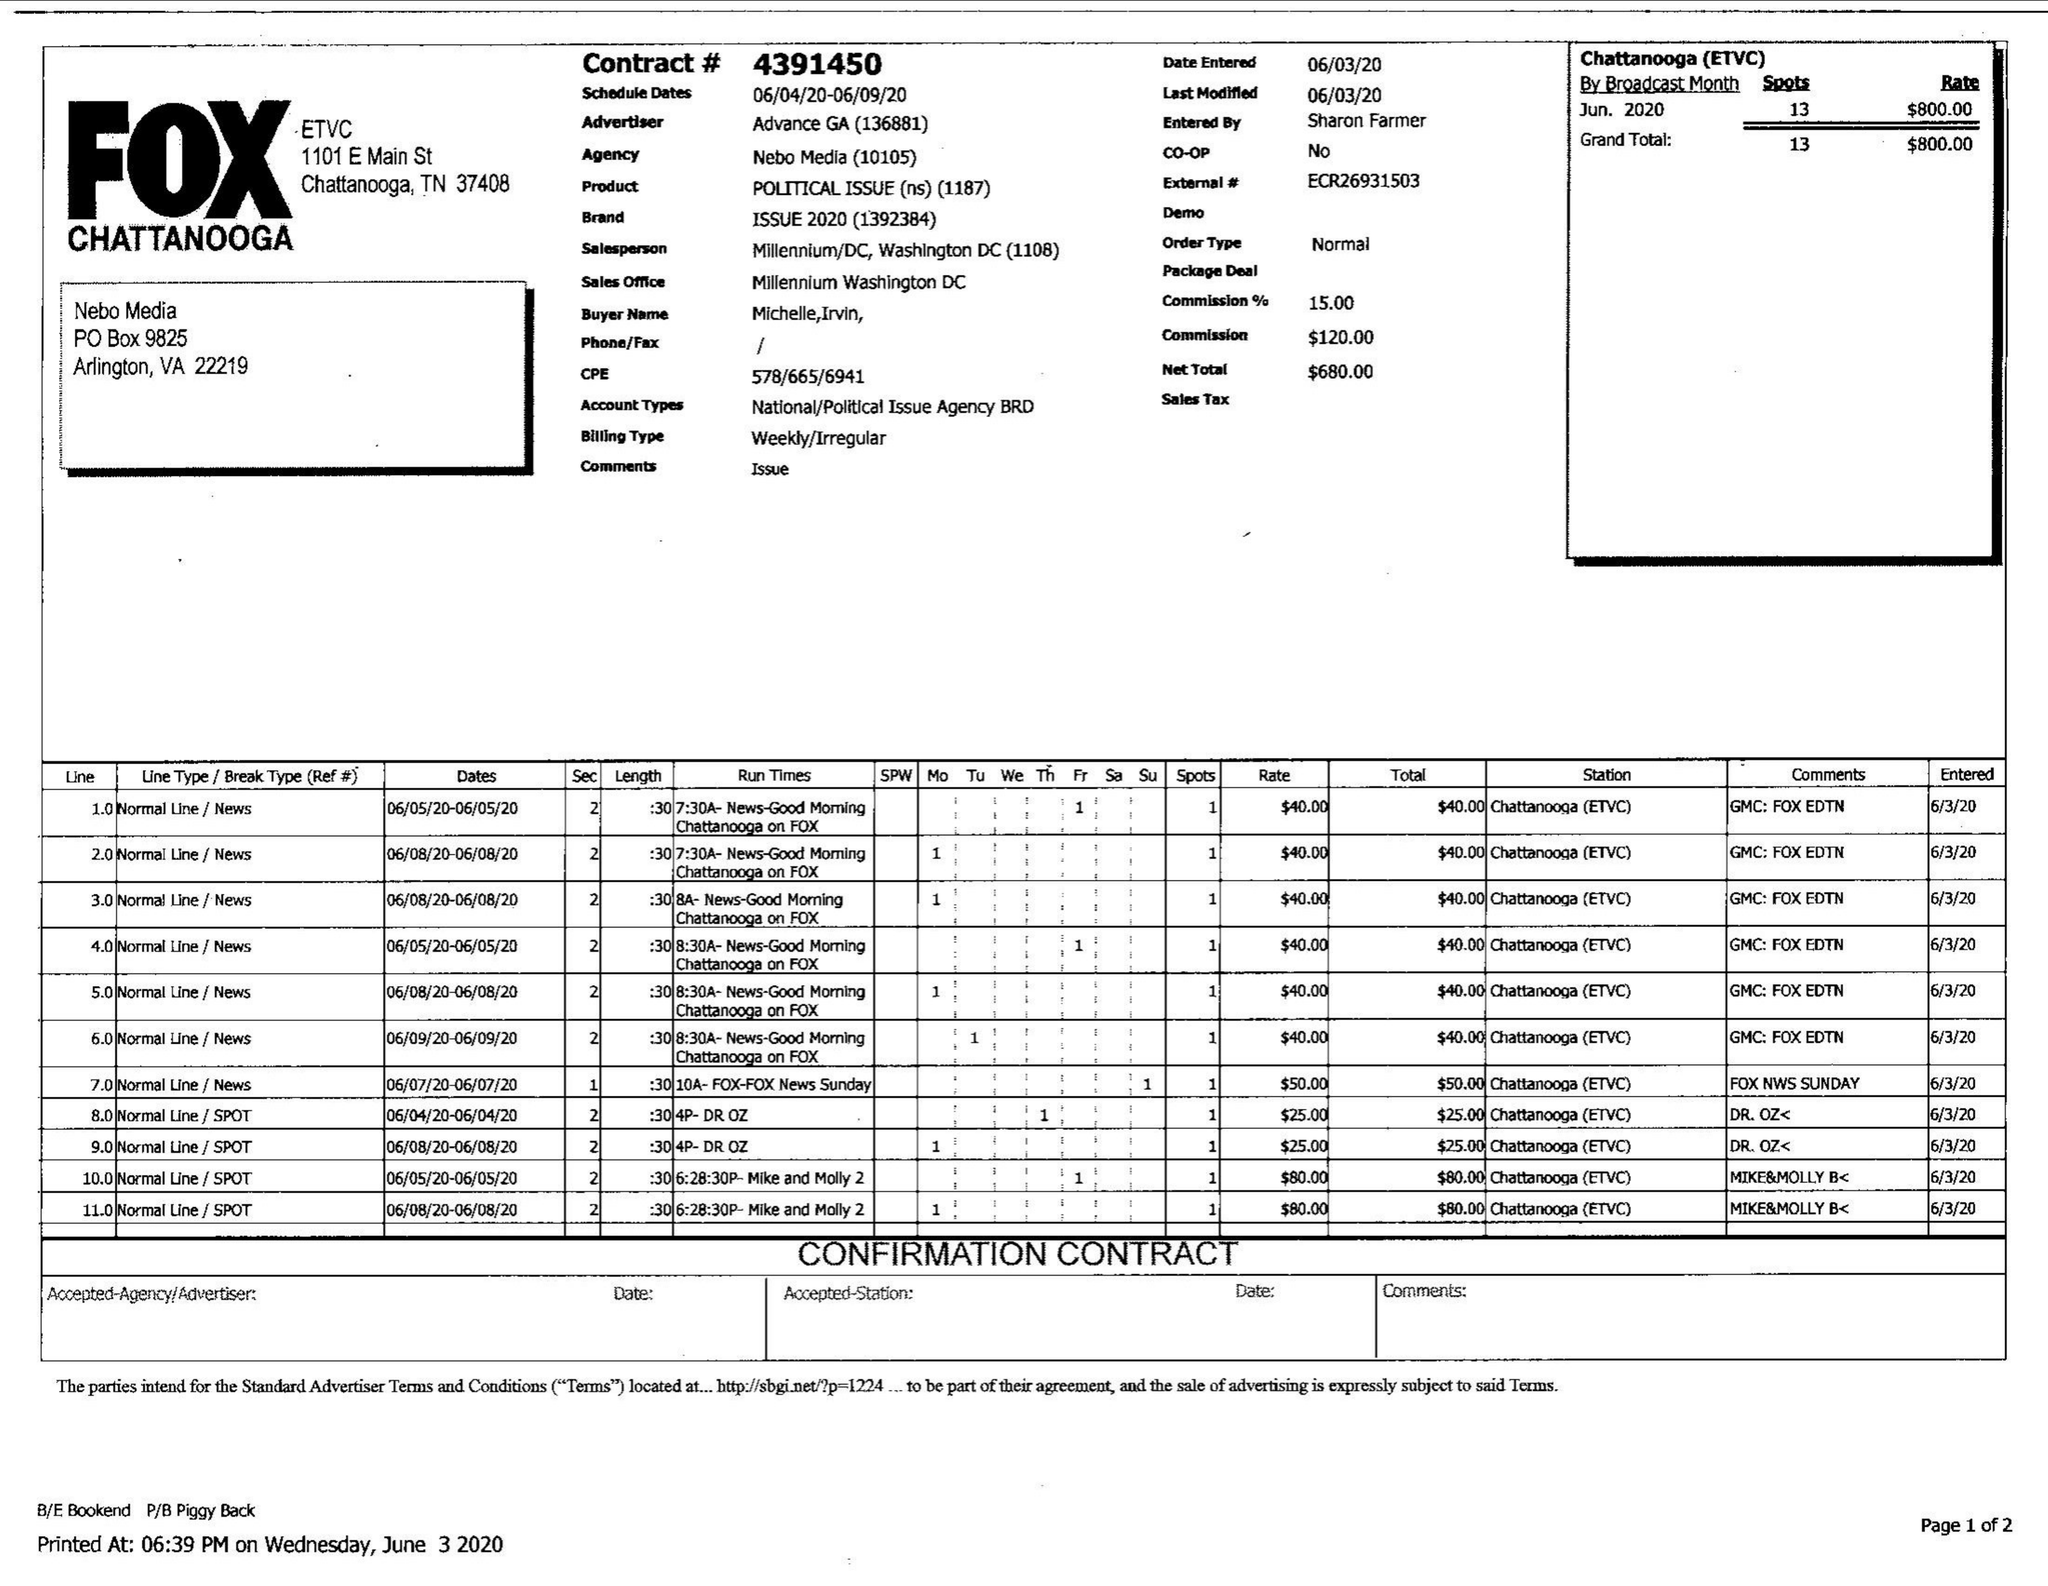What is the value for the gross_amount?
Answer the question using a single word or phrase. 800.00 